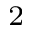<formula> <loc_0><loc_0><loc_500><loc_500>^ { 2 }</formula> 